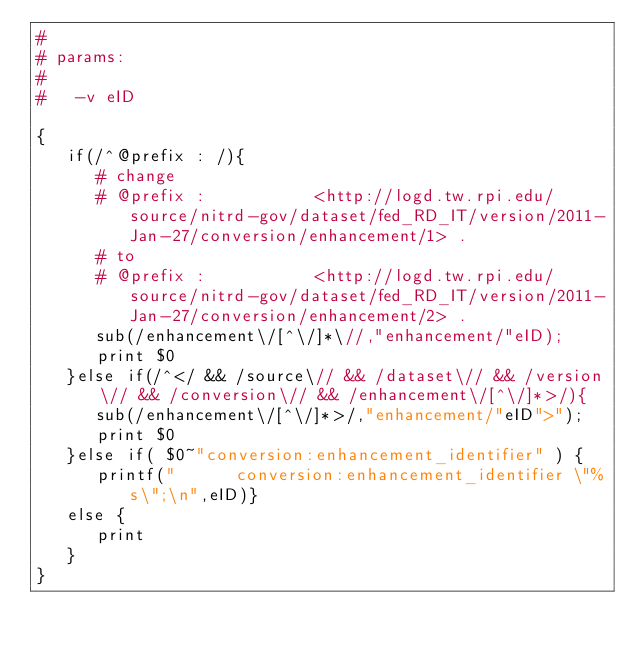<code> <loc_0><loc_0><loc_500><loc_500><_Awk_>#
# params: 
#
#   -v eID

{
   if(/^@prefix : /){
      # change
      # @prefix :           <http://logd.tw.rpi.edu/source/nitrd-gov/dataset/fed_RD_IT/version/2011-Jan-27/conversion/enhancement/1> .
      # to
      # @prefix :           <http://logd.tw.rpi.edu/source/nitrd-gov/dataset/fed_RD_IT/version/2011-Jan-27/conversion/enhancement/2> .
      sub(/enhancement\/[^\/]*\//,"enhancement/"eID);
      print $0
   }else if(/^</ && /source\// && /dataset\// && /version\// && /conversion\// && /enhancement\/[^\/]*>/){
      sub(/enhancement\/[^\/]*>/,"enhancement/"eID">");
      print $0
   }else if( $0~"conversion:enhancement_identifier" ) {
      printf("      conversion:enhancement_identifier \"%s\";\n",eID)}
   else {
      print
   }
}
</code> 